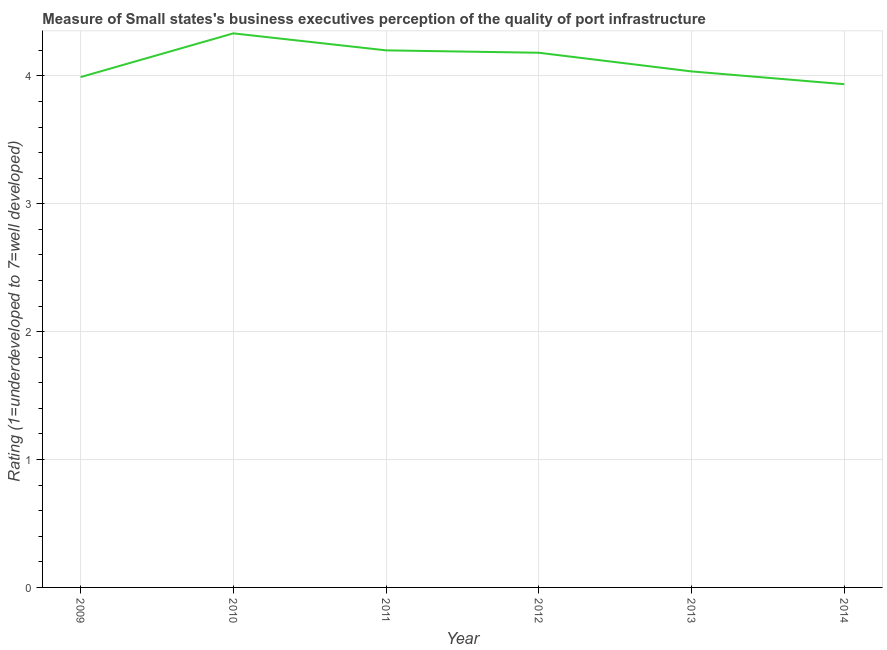What is the rating measuring quality of port infrastructure in 2012?
Make the answer very short. 4.18. Across all years, what is the maximum rating measuring quality of port infrastructure?
Provide a short and direct response. 4.33. Across all years, what is the minimum rating measuring quality of port infrastructure?
Your response must be concise. 3.94. What is the sum of the rating measuring quality of port infrastructure?
Offer a very short reply. 24.68. What is the difference between the rating measuring quality of port infrastructure in 2010 and 2013?
Offer a terse response. 0.3. What is the average rating measuring quality of port infrastructure per year?
Make the answer very short. 4.11. What is the median rating measuring quality of port infrastructure?
Keep it short and to the point. 4.11. What is the ratio of the rating measuring quality of port infrastructure in 2011 to that in 2014?
Offer a very short reply. 1.07. What is the difference between the highest and the second highest rating measuring quality of port infrastructure?
Provide a short and direct response. 0.13. What is the difference between the highest and the lowest rating measuring quality of port infrastructure?
Provide a succinct answer. 0.4. In how many years, is the rating measuring quality of port infrastructure greater than the average rating measuring quality of port infrastructure taken over all years?
Your response must be concise. 3. Does the rating measuring quality of port infrastructure monotonically increase over the years?
Provide a short and direct response. No. What is the difference between two consecutive major ticks on the Y-axis?
Ensure brevity in your answer.  1. Are the values on the major ticks of Y-axis written in scientific E-notation?
Ensure brevity in your answer.  No. Does the graph contain any zero values?
Give a very brief answer. No. What is the title of the graph?
Your answer should be very brief. Measure of Small states's business executives perception of the quality of port infrastructure. What is the label or title of the Y-axis?
Give a very brief answer. Rating (1=underdeveloped to 7=well developed) . What is the Rating (1=underdeveloped to 7=well developed)  of 2009?
Your answer should be compact. 3.99. What is the Rating (1=underdeveloped to 7=well developed)  of 2010?
Ensure brevity in your answer.  4.33. What is the Rating (1=underdeveloped to 7=well developed)  of 2011?
Offer a very short reply. 4.2. What is the Rating (1=underdeveloped to 7=well developed)  of 2012?
Your answer should be compact. 4.18. What is the Rating (1=underdeveloped to 7=well developed)  in 2013?
Provide a succinct answer. 4.04. What is the Rating (1=underdeveloped to 7=well developed)  in 2014?
Keep it short and to the point. 3.94. What is the difference between the Rating (1=underdeveloped to 7=well developed)  in 2009 and 2010?
Provide a short and direct response. -0.34. What is the difference between the Rating (1=underdeveloped to 7=well developed)  in 2009 and 2011?
Provide a short and direct response. -0.21. What is the difference between the Rating (1=underdeveloped to 7=well developed)  in 2009 and 2012?
Your response must be concise. -0.19. What is the difference between the Rating (1=underdeveloped to 7=well developed)  in 2009 and 2013?
Give a very brief answer. -0.04. What is the difference between the Rating (1=underdeveloped to 7=well developed)  in 2009 and 2014?
Offer a very short reply. 0.06. What is the difference between the Rating (1=underdeveloped to 7=well developed)  in 2010 and 2011?
Offer a terse response. 0.13. What is the difference between the Rating (1=underdeveloped to 7=well developed)  in 2010 and 2012?
Offer a terse response. 0.15. What is the difference between the Rating (1=underdeveloped to 7=well developed)  in 2010 and 2013?
Provide a succinct answer. 0.3. What is the difference between the Rating (1=underdeveloped to 7=well developed)  in 2010 and 2014?
Your answer should be compact. 0.4. What is the difference between the Rating (1=underdeveloped to 7=well developed)  in 2011 and 2012?
Keep it short and to the point. 0.02. What is the difference between the Rating (1=underdeveloped to 7=well developed)  in 2011 and 2013?
Offer a very short reply. 0.16. What is the difference between the Rating (1=underdeveloped to 7=well developed)  in 2011 and 2014?
Offer a very short reply. 0.26. What is the difference between the Rating (1=underdeveloped to 7=well developed)  in 2012 and 2013?
Make the answer very short. 0.15. What is the difference between the Rating (1=underdeveloped to 7=well developed)  in 2012 and 2014?
Your response must be concise. 0.25. What is the ratio of the Rating (1=underdeveloped to 7=well developed)  in 2009 to that in 2010?
Ensure brevity in your answer.  0.92. What is the ratio of the Rating (1=underdeveloped to 7=well developed)  in 2009 to that in 2012?
Ensure brevity in your answer.  0.95. What is the ratio of the Rating (1=underdeveloped to 7=well developed)  in 2009 to that in 2013?
Keep it short and to the point. 0.99. What is the ratio of the Rating (1=underdeveloped to 7=well developed)  in 2010 to that in 2011?
Ensure brevity in your answer.  1.03. What is the ratio of the Rating (1=underdeveloped to 7=well developed)  in 2010 to that in 2012?
Offer a very short reply. 1.04. What is the ratio of the Rating (1=underdeveloped to 7=well developed)  in 2010 to that in 2013?
Your response must be concise. 1.07. What is the ratio of the Rating (1=underdeveloped to 7=well developed)  in 2010 to that in 2014?
Offer a very short reply. 1.1. What is the ratio of the Rating (1=underdeveloped to 7=well developed)  in 2011 to that in 2013?
Give a very brief answer. 1.04. What is the ratio of the Rating (1=underdeveloped to 7=well developed)  in 2011 to that in 2014?
Your answer should be very brief. 1.07. What is the ratio of the Rating (1=underdeveloped to 7=well developed)  in 2012 to that in 2013?
Provide a succinct answer. 1.04. What is the ratio of the Rating (1=underdeveloped to 7=well developed)  in 2012 to that in 2014?
Make the answer very short. 1.06. What is the ratio of the Rating (1=underdeveloped to 7=well developed)  in 2013 to that in 2014?
Give a very brief answer. 1.02. 